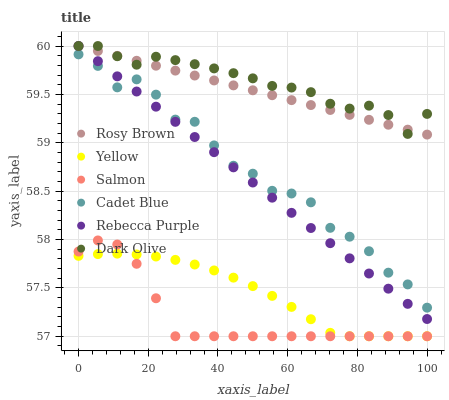Does Salmon have the minimum area under the curve?
Answer yes or no. Yes. Does Dark Olive have the maximum area under the curve?
Answer yes or no. Yes. Does Dark Olive have the minimum area under the curve?
Answer yes or no. No. Does Salmon have the maximum area under the curve?
Answer yes or no. No. Is Rebecca Purple the smoothest?
Answer yes or no. Yes. Is Cadet Blue the roughest?
Answer yes or no. Yes. Is Dark Olive the smoothest?
Answer yes or no. No. Is Dark Olive the roughest?
Answer yes or no. No. Does Salmon have the lowest value?
Answer yes or no. Yes. Does Dark Olive have the lowest value?
Answer yes or no. No. Does Rosy Brown have the highest value?
Answer yes or no. Yes. Does Salmon have the highest value?
Answer yes or no. No. Is Salmon less than Rebecca Purple?
Answer yes or no. Yes. Is Rosy Brown greater than Yellow?
Answer yes or no. Yes. Does Dark Olive intersect Rosy Brown?
Answer yes or no. Yes. Is Dark Olive less than Rosy Brown?
Answer yes or no. No. Is Dark Olive greater than Rosy Brown?
Answer yes or no. No. Does Salmon intersect Rebecca Purple?
Answer yes or no. No. 